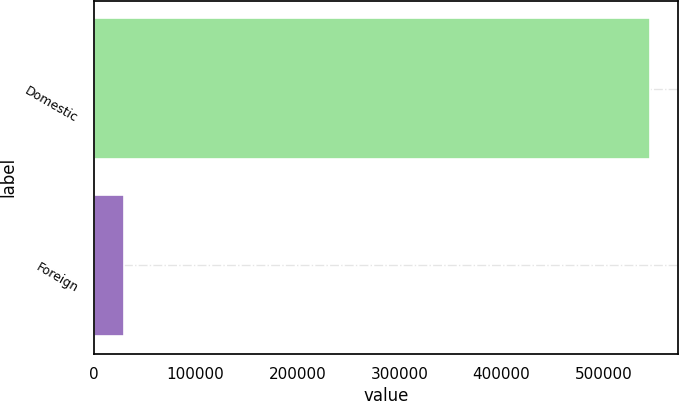Convert chart to OTSL. <chart><loc_0><loc_0><loc_500><loc_500><bar_chart><fcel>Domestic<fcel>Foreign<nl><fcel>545527<fcel>29554<nl></chart> 